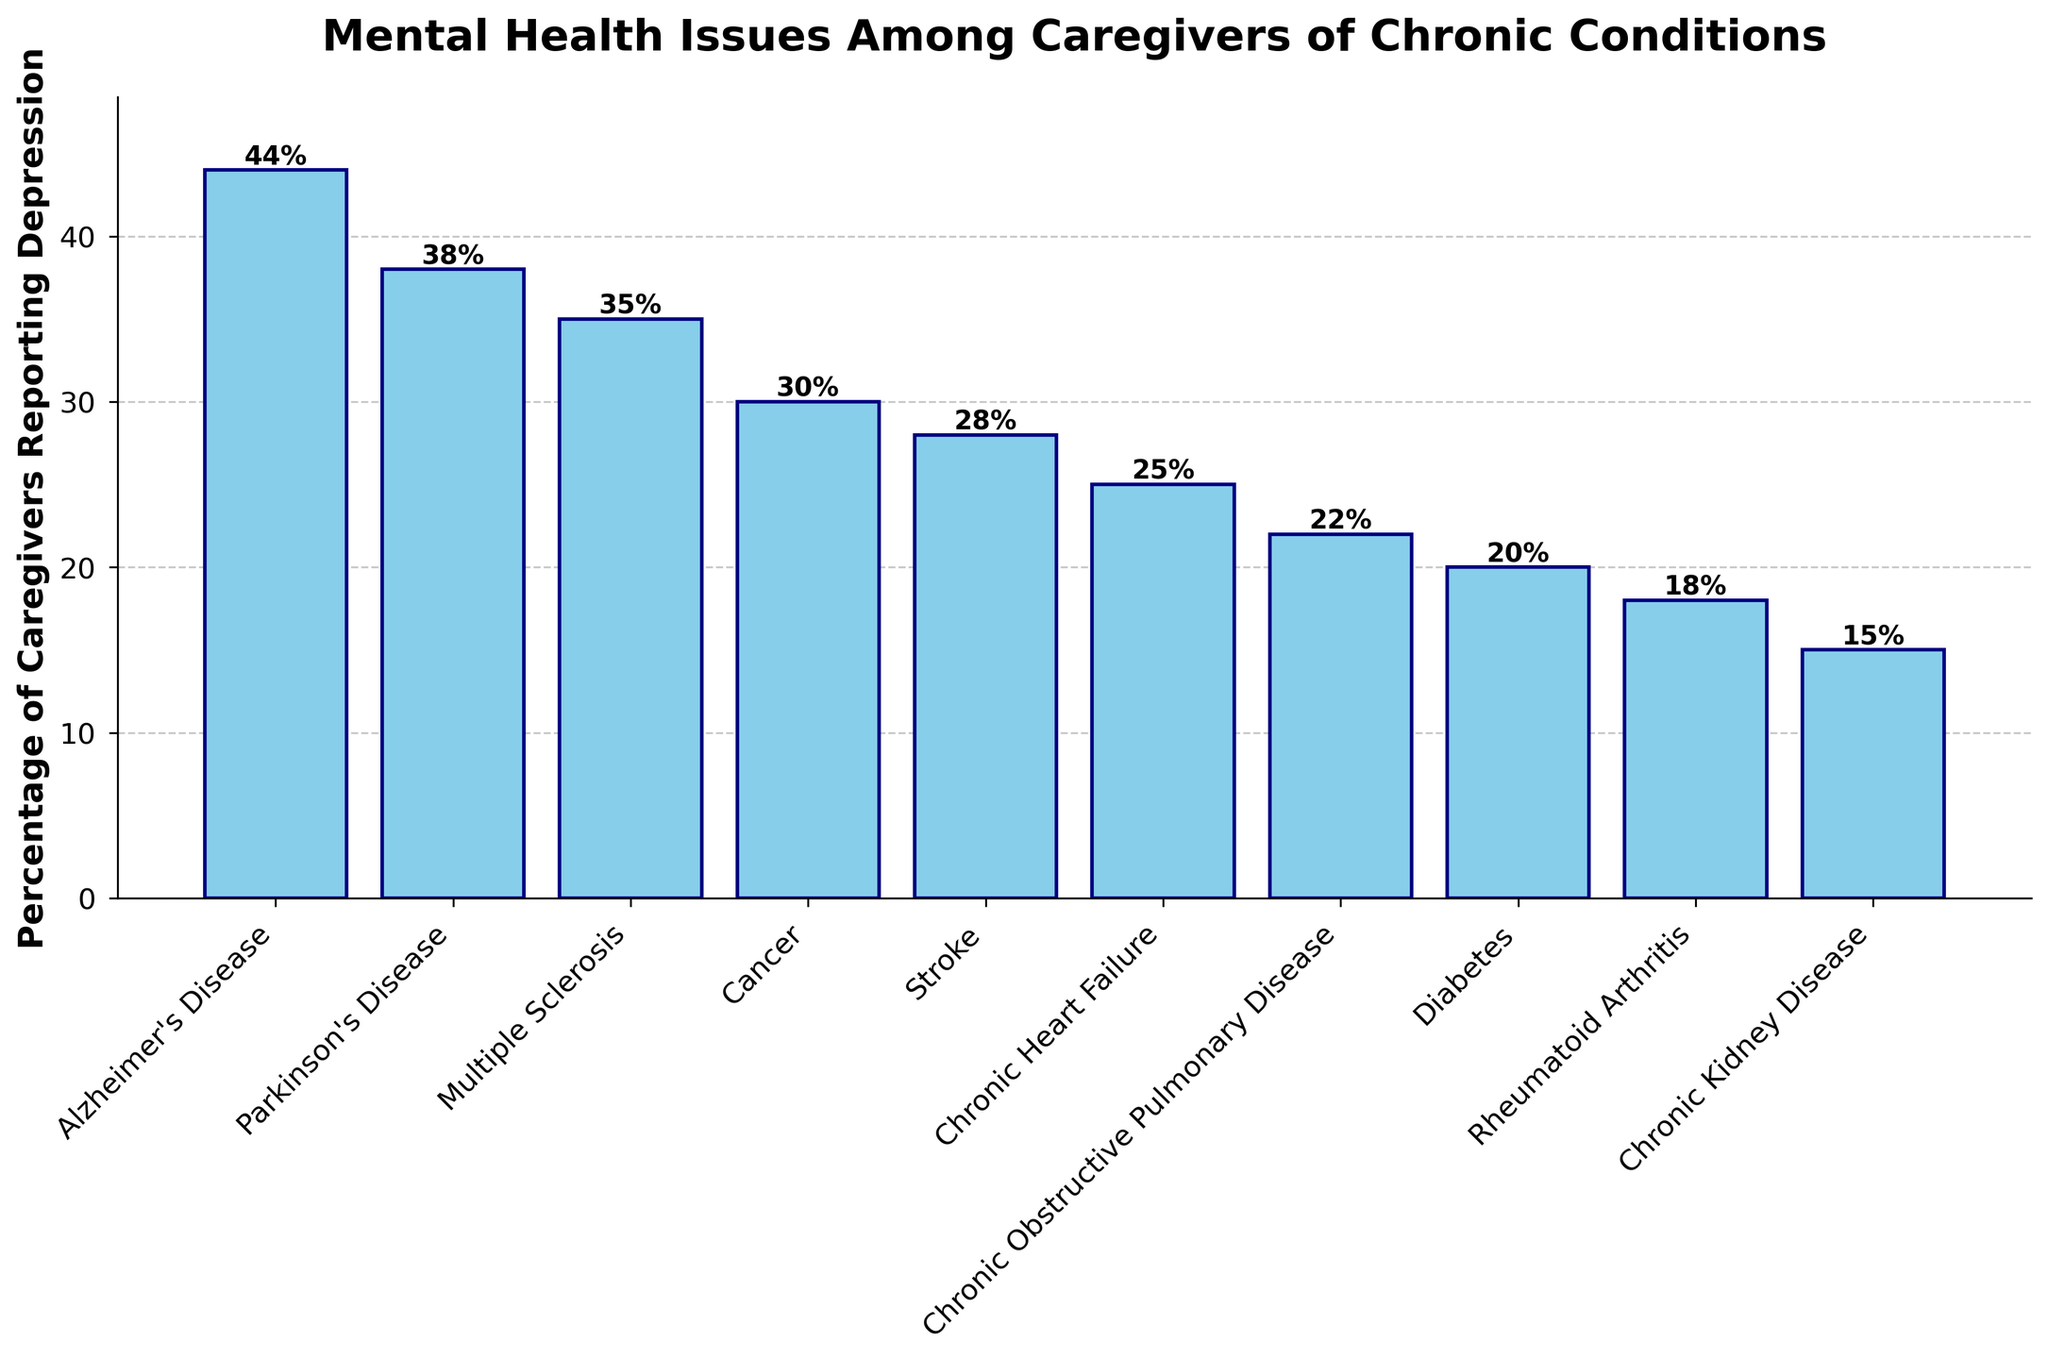What's the percentage of caregivers reporting depression for Alzheimer's Disease compared to Diabetes? The bar representing Alzheimer's Disease shows a height of 44%, and the bar representing Diabetes shows a height of 20%. Comparing these values, Alzheimer's Disease has a higher percentage.
Answer: Alzheimer's Disease: 44%, Diabetes: 20% Which chronic condition has the lowest percentage of caregivers reporting depression? Among the bars representing the conditions, the one for Chronic Kidney Disease is the shortest, indicating the lowest percentage, which is 15%.
Answer: Chronic Kidney Disease What is the sum of the percentages for Alzheimer's Disease and Parkinson's Disease? Alzheimer's Disease has a percentage of 44%, and Parkinson's Disease has 38%. Adding these together: 44 + 38 = 82.
Answer: 82% How does the percentage of caregivers reporting depression for Cancer compare to that for Chronic Heart Failure? The bar for Cancer shows 30%, whereas the bar for Chronic Heart Failure shows 25%. Cancer has a higher percentage of caregivers reporting depression than Chronic Heart Failure.
Answer: Cancer: 30%, Chronic Heart Failure: 25% What is the average percentage of caregivers reporting depression for Stroke, Chronic Heart Failure, and Chronic Obstructive Pulmonary Disease? Summing the percentages for Stroke (28%), Chronic Heart Failure (25%), and Chronic Obstructive Pulmonary Disease (22%) gives us 28 + 25 + 22 = 75. Dividing by the number of conditions (3): 75 / 3 = 25.
Answer: 25% Which condition has a higher percentage of caregivers reporting depression, Multiple Sclerosis or Rheumatoid Arthritis? The bar for Multiple Sclerosis shows 35%, whereas the bar for Rheumatoid Arthritis shows 18%. Multiple Sclerosis has a higher percentage.
Answer: Multiple Sclerosis: 35%, Rheumatoid Arthritis: 18% What is the difference in the percentage of caregivers reporting depression between Chronic Obstructive Pulmonary Disease and Diabetes? The bar for Chronic Obstructive Pulmonary Disease indicates 22%, and the bar for Diabetes indicates 20%. Subtracting these values: 22 - 20 = 2.
Answer: 2% Which condition's caregivers report depression at a rate closest to the average percentage across all conditions? To find the average, first sum all percentages: 44 + 38 + 35 + 30 + 28 + 25 + 22 + 20 + 18 + 15 = 275. Dividing by the number of conditions (10): 275 / 10 = 27.5%. The condition closest to this average is Stroke at 28%.
Answer: Stroke What is the range of percentages reported in the figure? To calculate the range, subtract the lowest percentage (Chronic Kidney Disease, 15%) from the highest percentage (Alzheimer's Disease, 44%): 44 - 15 = 29.
Answer: 29% How many conditions have a percentage of caregivers reporting depression higher than 30%? Counting the conditions with percentages higher than 30%: Alzheimer's Disease (44%), Parkinson's Disease (38%), Multiple Sclerosis (35%), and Cancer (30%, note not >30%). Therefore, three conditions meet the criteria.
Answer: 3 